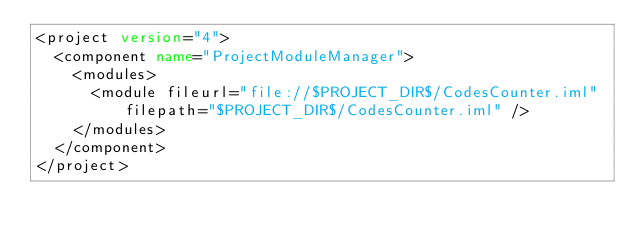<code> <loc_0><loc_0><loc_500><loc_500><_XML_><project version="4">
  <component name="ProjectModuleManager">
    <modules>
      <module fileurl="file://$PROJECT_DIR$/CodesCounter.iml" filepath="$PROJECT_DIR$/CodesCounter.iml" />
    </modules>
  </component>
</project></code> 